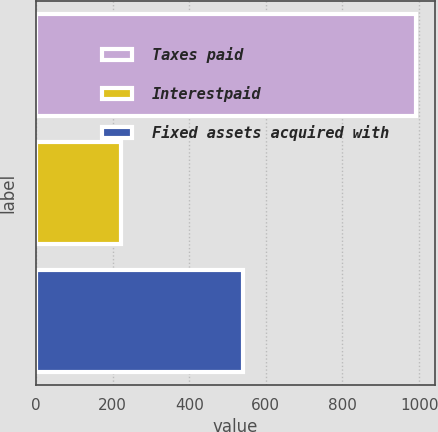<chart> <loc_0><loc_0><loc_500><loc_500><bar_chart><fcel>Taxes paid<fcel>Interestpaid<fcel>Fixed assets acquired with<nl><fcel>992<fcel>223<fcel>541<nl></chart> 